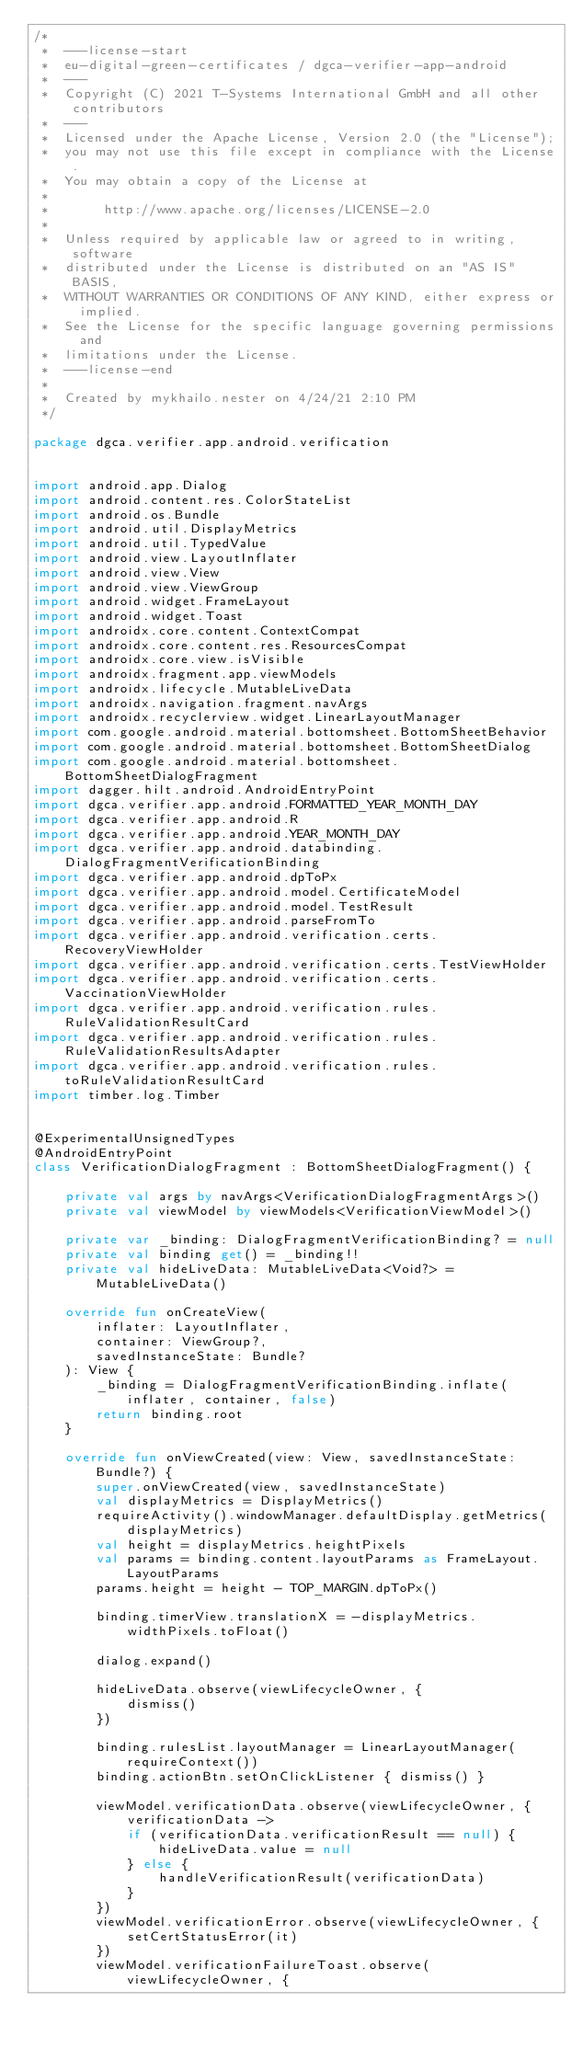Convert code to text. <code><loc_0><loc_0><loc_500><loc_500><_Kotlin_>/*
 *  ---license-start
 *  eu-digital-green-certificates / dgca-verifier-app-android
 *  ---
 *  Copyright (C) 2021 T-Systems International GmbH and all other contributors
 *  ---
 *  Licensed under the Apache License, Version 2.0 (the "License");
 *  you may not use this file except in compliance with the License.
 *  You may obtain a copy of the License at
 *
 *       http://www.apache.org/licenses/LICENSE-2.0
 *
 *  Unless required by applicable law or agreed to in writing, software
 *  distributed under the License is distributed on an "AS IS" BASIS,
 *  WITHOUT WARRANTIES OR CONDITIONS OF ANY KIND, either express or implied.
 *  See the License for the specific language governing permissions and
 *  limitations under the License.
 *  ---license-end
 *
 *  Created by mykhailo.nester on 4/24/21 2:10 PM
 */

package dgca.verifier.app.android.verification


import android.app.Dialog
import android.content.res.ColorStateList
import android.os.Bundle
import android.util.DisplayMetrics
import android.util.TypedValue
import android.view.LayoutInflater
import android.view.View
import android.view.ViewGroup
import android.widget.FrameLayout
import android.widget.Toast
import androidx.core.content.ContextCompat
import androidx.core.content.res.ResourcesCompat
import androidx.core.view.isVisible
import androidx.fragment.app.viewModels
import androidx.lifecycle.MutableLiveData
import androidx.navigation.fragment.navArgs
import androidx.recyclerview.widget.LinearLayoutManager
import com.google.android.material.bottomsheet.BottomSheetBehavior
import com.google.android.material.bottomsheet.BottomSheetDialog
import com.google.android.material.bottomsheet.BottomSheetDialogFragment
import dagger.hilt.android.AndroidEntryPoint
import dgca.verifier.app.android.FORMATTED_YEAR_MONTH_DAY
import dgca.verifier.app.android.R
import dgca.verifier.app.android.YEAR_MONTH_DAY
import dgca.verifier.app.android.databinding.DialogFragmentVerificationBinding
import dgca.verifier.app.android.dpToPx
import dgca.verifier.app.android.model.CertificateModel
import dgca.verifier.app.android.model.TestResult
import dgca.verifier.app.android.parseFromTo
import dgca.verifier.app.android.verification.certs.RecoveryViewHolder
import dgca.verifier.app.android.verification.certs.TestViewHolder
import dgca.verifier.app.android.verification.certs.VaccinationViewHolder
import dgca.verifier.app.android.verification.rules.RuleValidationResultCard
import dgca.verifier.app.android.verification.rules.RuleValidationResultsAdapter
import dgca.verifier.app.android.verification.rules.toRuleValidationResultCard
import timber.log.Timber


@ExperimentalUnsignedTypes
@AndroidEntryPoint
class VerificationDialogFragment : BottomSheetDialogFragment() {

    private val args by navArgs<VerificationDialogFragmentArgs>()
    private val viewModel by viewModels<VerificationViewModel>()

    private var _binding: DialogFragmentVerificationBinding? = null
    private val binding get() = _binding!!
    private val hideLiveData: MutableLiveData<Void?> = MutableLiveData()

    override fun onCreateView(
        inflater: LayoutInflater,
        container: ViewGroup?,
        savedInstanceState: Bundle?
    ): View {
        _binding = DialogFragmentVerificationBinding.inflate(inflater, container, false)
        return binding.root
    }

    override fun onViewCreated(view: View, savedInstanceState: Bundle?) {
        super.onViewCreated(view, savedInstanceState)
        val displayMetrics = DisplayMetrics()
        requireActivity().windowManager.defaultDisplay.getMetrics(displayMetrics)
        val height = displayMetrics.heightPixels
        val params = binding.content.layoutParams as FrameLayout.LayoutParams
        params.height = height - TOP_MARGIN.dpToPx()

        binding.timerView.translationX = -displayMetrics.widthPixels.toFloat()

        dialog.expand()

        hideLiveData.observe(viewLifecycleOwner, {
            dismiss()
        })

        binding.rulesList.layoutManager = LinearLayoutManager(requireContext())
        binding.actionBtn.setOnClickListener { dismiss() }

        viewModel.verificationData.observe(viewLifecycleOwner, { verificationData ->
            if (verificationData.verificationResult == null) {
                hideLiveData.value = null
            } else {
                handleVerificationResult(verificationData)
            }
        })
        viewModel.verificationError.observe(viewLifecycleOwner, {
            setCertStatusError(it)
        })
        viewModel.verificationFailureToast.observe(viewLifecycleOwner, {</code> 